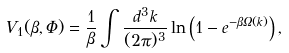<formula> <loc_0><loc_0><loc_500><loc_500>V _ { 1 } ( \beta , \Phi ) = \frac { 1 } { \beta } \int \frac { d ^ { 3 } k } { ( 2 \pi ) ^ { 3 } } \ln \left ( 1 - e ^ { - \beta \Omega ( k ) } \right ) ,</formula> 